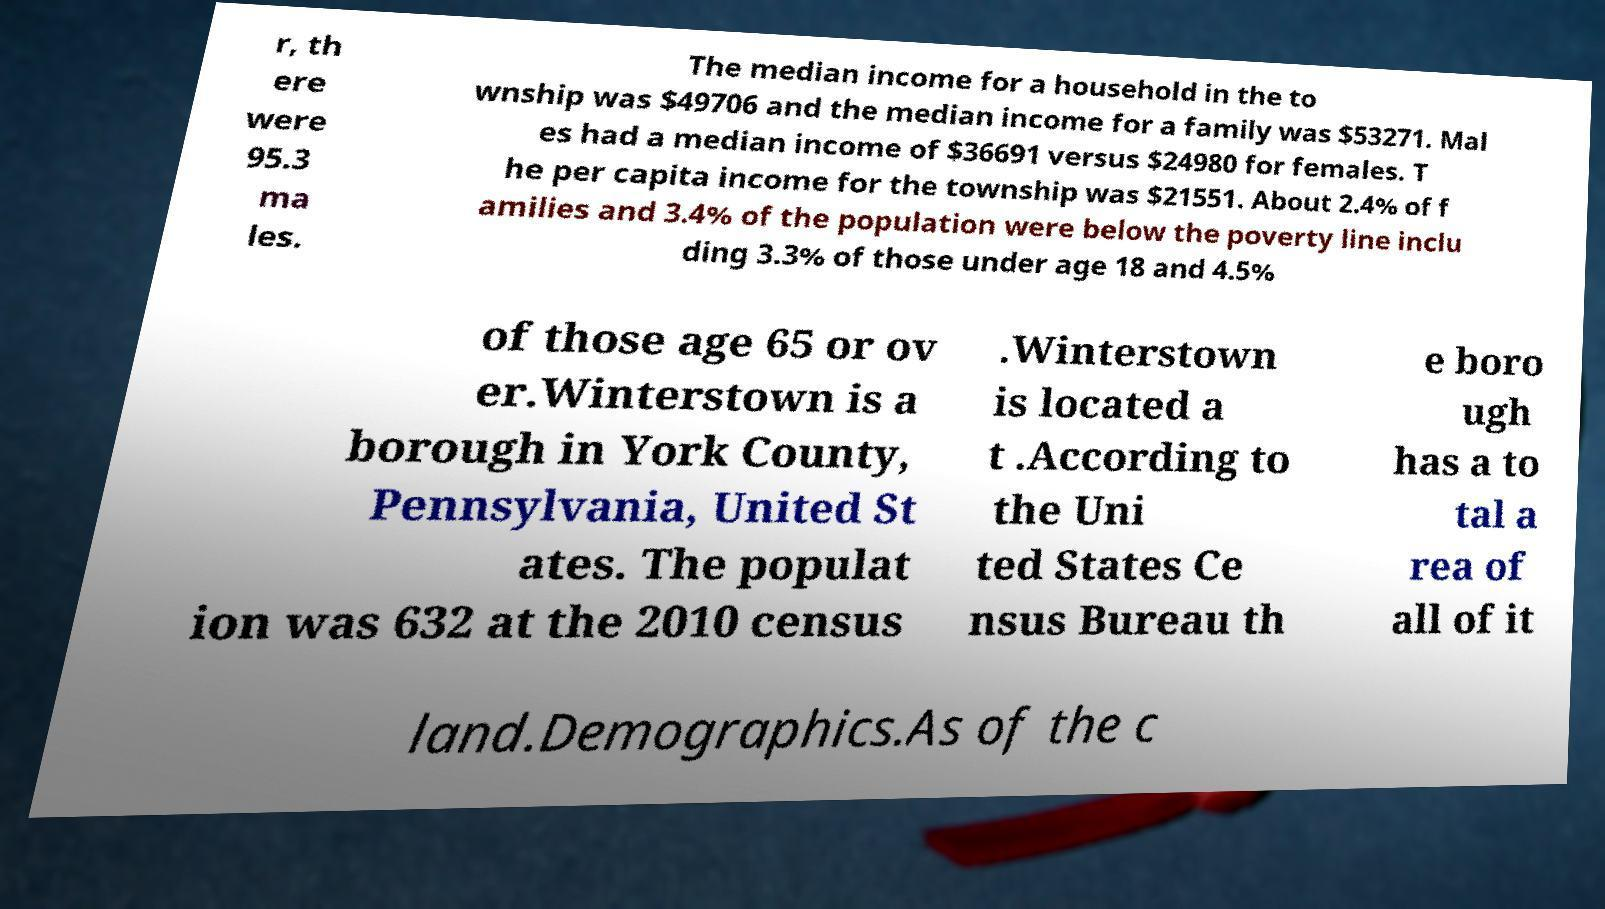Please read and relay the text visible in this image. What does it say? r, th ere were 95.3 ma les. The median income for a household in the to wnship was $49706 and the median income for a family was $53271. Mal es had a median income of $36691 versus $24980 for females. T he per capita income for the township was $21551. About 2.4% of f amilies and 3.4% of the population were below the poverty line inclu ding 3.3% of those under age 18 and 4.5% of those age 65 or ov er.Winterstown is a borough in York County, Pennsylvania, United St ates. The populat ion was 632 at the 2010 census .Winterstown is located a t .According to the Uni ted States Ce nsus Bureau th e boro ugh has a to tal a rea of all of it land.Demographics.As of the c 